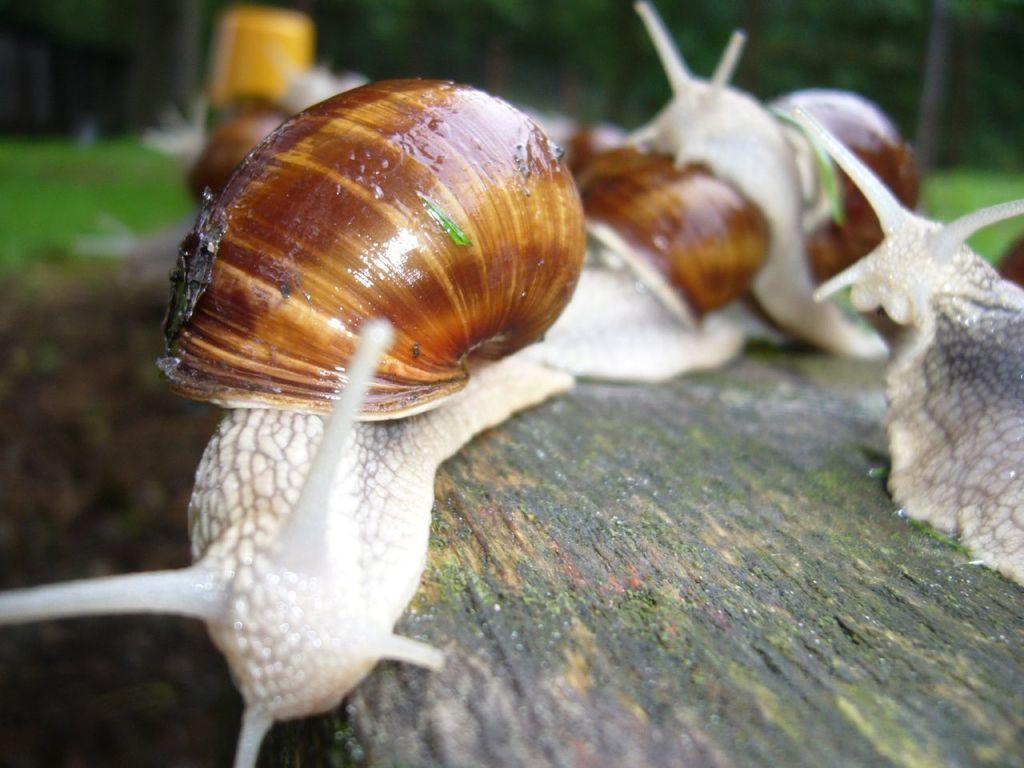Could you give a brief overview of what you see in this image? Here we can see insects. There is a blur background with greenery. 